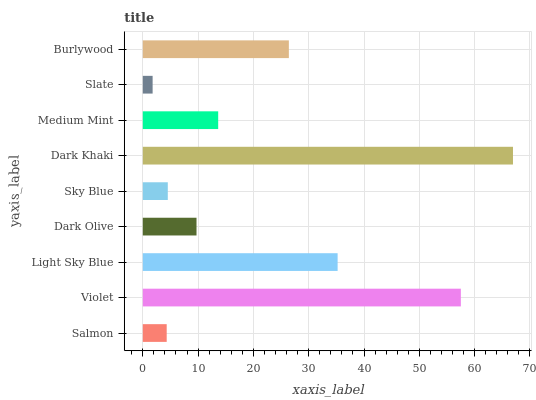Is Slate the minimum?
Answer yes or no. Yes. Is Dark Khaki the maximum?
Answer yes or no. Yes. Is Violet the minimum?
Answer yes or no. No. Is Violet the maximum?
Answer yes or no. No. Is Violet greater than Salmon?
Answer yes or no. Yes. Is Salmon less than Violet?
Answer yes or no. Yes. Is Salmon greater than Violet?
Answer yes or no. No. Is Violet less than Salmon?
Answer yes or no. No. Is Medium Mint the high median?
Answer yes or no. Yes. Is Medium Mint the low median?
Answer yes or no. Yes. Is Violet the high median?
Answer yes or no. No. Is Burlywood the low median?
Answer yes or no. No. 